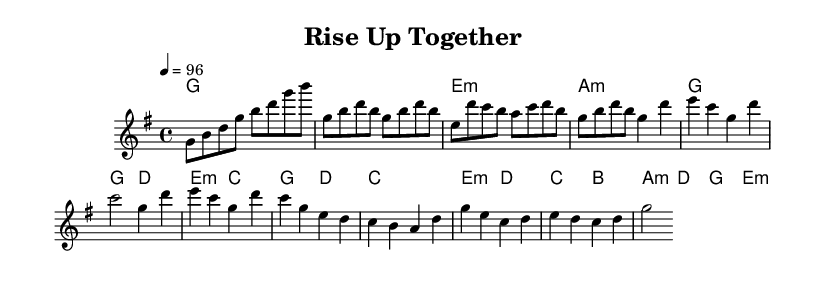What is the key signature of this music? The key signature shows one sharp, which is consistent with G major. A key signature with one sharp indicates that F# is included.
Answer: G major What is the time signature of this music? The time signature is represented by the numbers above the staff, indicating that there are four beats in each measure and the quarter note receives one beat.
Answer: 4/4 What is the tempo marking in this music? The tempo marking is indicated at the beginning of the score, showing that the piece is to be played at a speed of 96 beats per minute. This means that there are 96 quarter notes in one minute.
Answer: 96 How many measures are in the verse section? By counting the measures in the verse section specifically defined in the music, there are four measures where the melody outlines distinct phrases.
Answer: 4 Identify the first chord in the chorus section. The chorus begins with the G chord, indicated at the start of that section. This can be identified by looking for the first chord notated in that part of the sheet music.
Answer: G What is the form of this piece? The form can be deduced from the structure laid out in the score, noting the distinct sections labeled as Intro, Verse, Chorus, and Bridge, indicating a typical verse-chorus structure commonly found in Rhythm and Blues.
Answer: Verse-Chorus What musical elements suggest this is an R&B anthem? The presence of strong backbeats, expressive melodies, and the themes of empowerment and community leadership in the lyrics (if present) characterize the piece as an R&B anthem. Evaluating the overall feel and rhythm can further accentuate this categorization.
Answer: Strong rhythm 